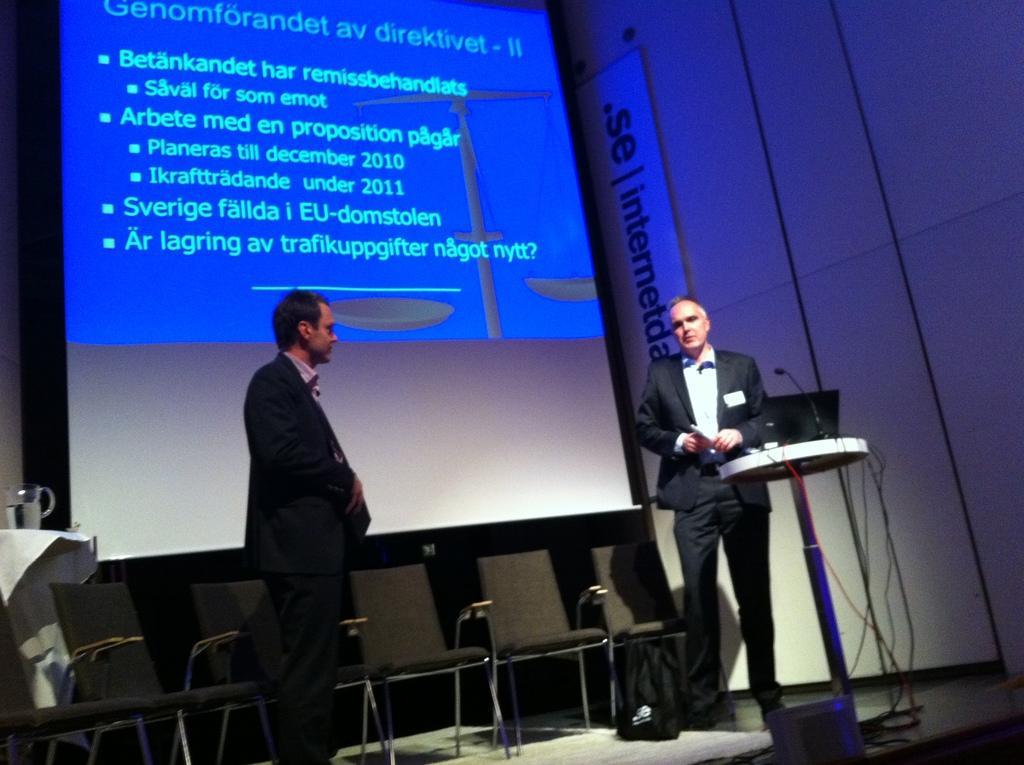Please provide a concise description of this image. In the picture I can see two men are standing on the stage. I can also see chairs, a laptop, a microphone, wires on the podium, a projector screen which has something displaying on it. On the left side I can see a glass object on the table. 